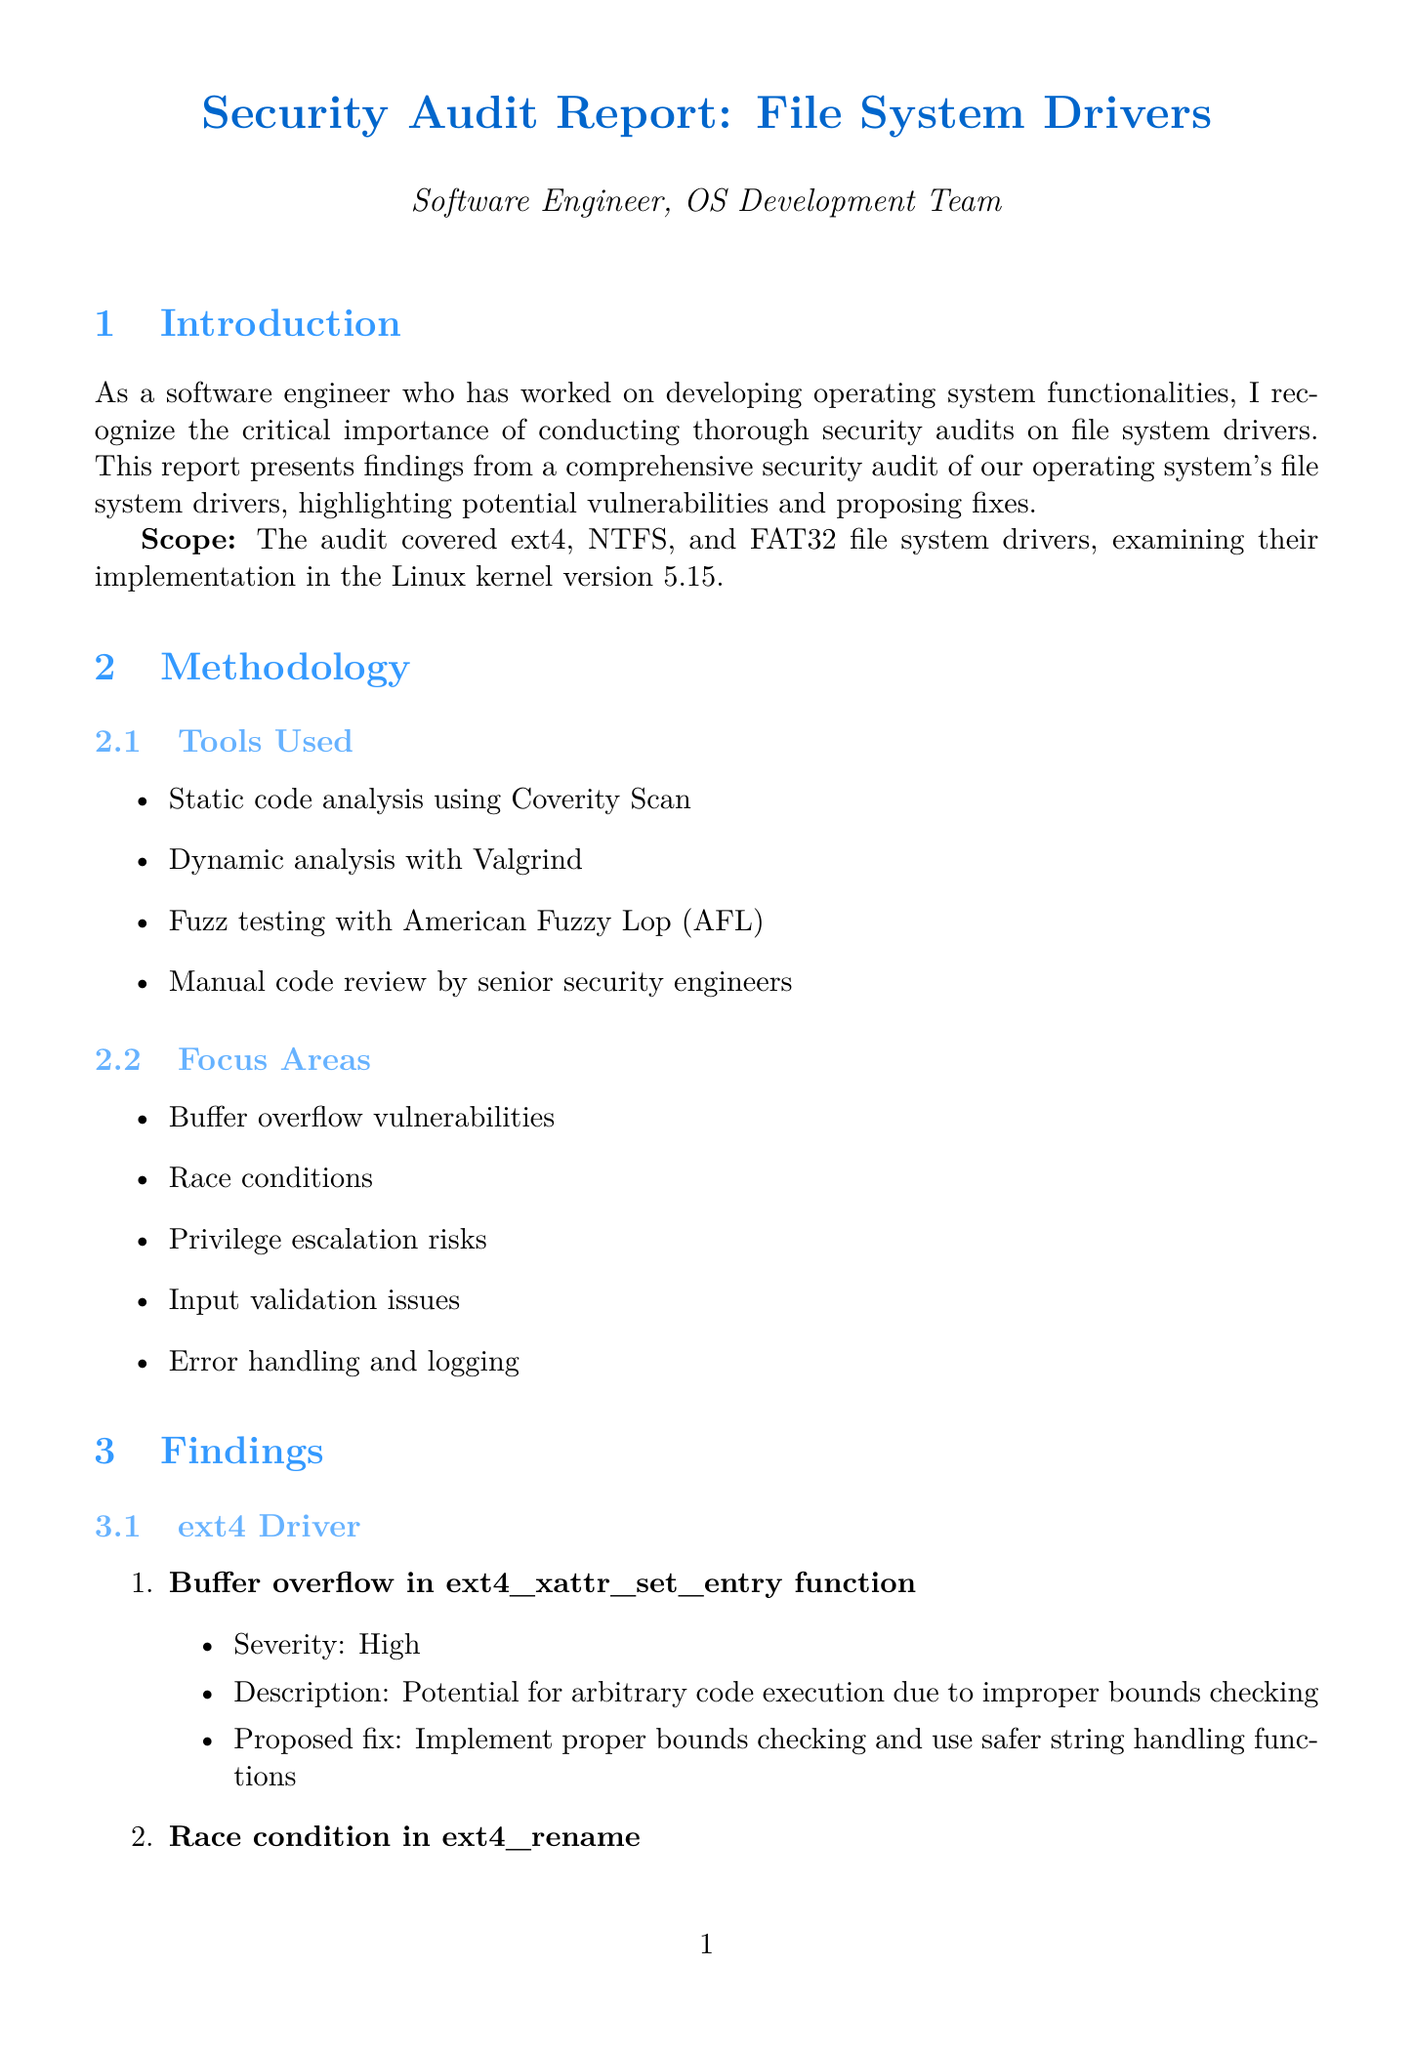what is the scope of the audit? The scope details the specific file system drivers and their implementation version that was examined in the audit.
Answer: ext4, NTFS, and FAT32 file system drivers, examining their implementation in the Linux kernel version 5.15 which tool was used for dynamic analysis? The document lists several tools used in the methodology section, indicating which was specifically for dynamic analysis.
Answer: Valgrind what is the severity level of the buffer overflow vulnerability in ext4? The severity levels of vulnerabilities are mentioned alongside each finding, specifically for the buffer overflow in ext4.
Answer: High how many vulnerabilities were identified in the NTFS driver? The count of vulnerabilities found in the NTFS section provides the answer to this question.
Answer: 2 what impact do ext4 vulnerabilities have? The impact analysis section summarizes the consequences of the ext4 vulnerabilities, indicating their broader influence.
Answer: Affect majority of Linux systems, potential for widespread exploitation what is one of the recommended actions for future security? The document outlines several recommended actions, and this asks for any single one of them to ensure clarity.
Answer: Prioritize fixing critical and high severity vulnerabilities what is the next step suggested in the conclusion? The conclusion provides directives for future actions, specifically the focus of immediate follow-up activities.
Answer: Form a dedicated task force to address the identified vulnerabilities and establish a timeline for implementing the proposed fixes 